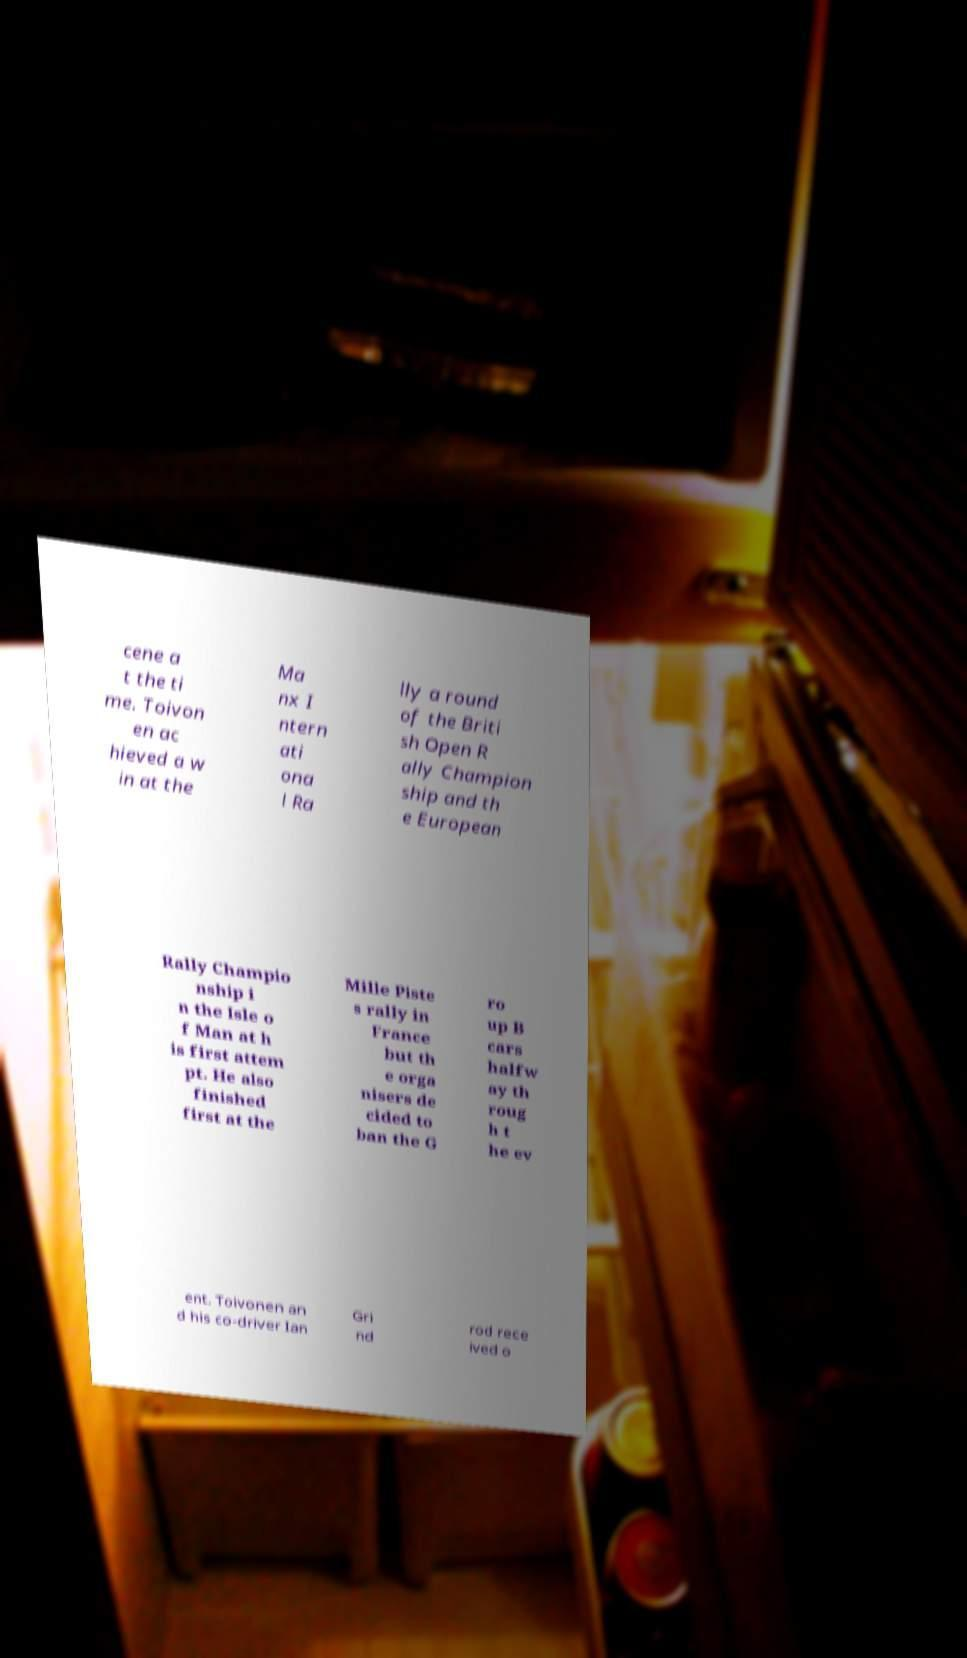What messages or text are displayed in this image? I need them in a readable, typed format. cene a t the ti me. Toivon en ac hieved a w in at the Ma nx I ntern ati ona l Ra lly a round of the Briti sh Open R ally Champion ship and th e European Rally Champio nship i n the Isle o f Man at h is first attem pt. He also finished first at the Mille Piste s rally in France but th e orga nisers de cided to ban the G ro up B cars halfw ay th roug h t he ev ent. Toivonen an d his co-driver Ian Gri nd rod rece ived o 